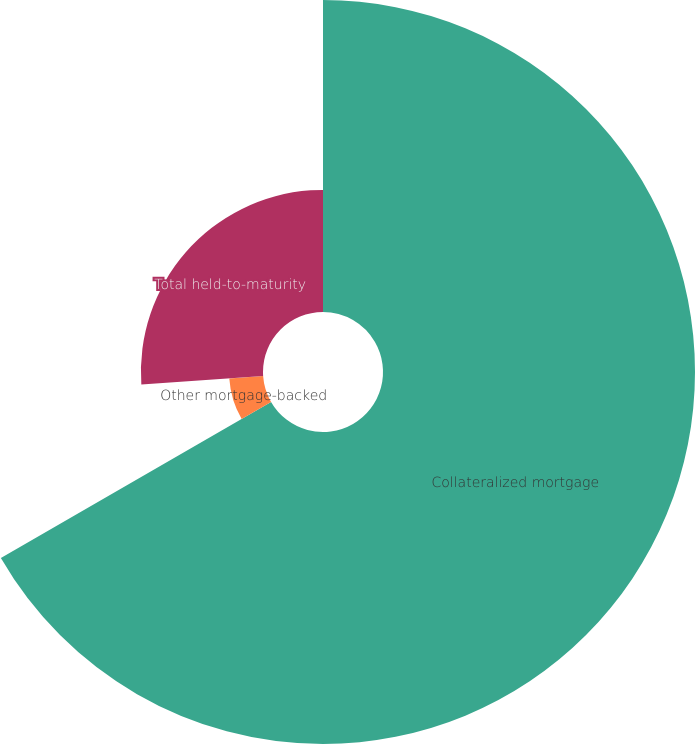Convert chart to OTSL. <chart><loc_0><loc_0><loc_500><loc_500><pie_chart><fcel>Collateralized mortgage<fcel>Other mortgage-backed<fcel>Total held-to-maturity<nl><fcel>66.67%<fcel>7.25%<fcel>26.09%<nl></chart> 